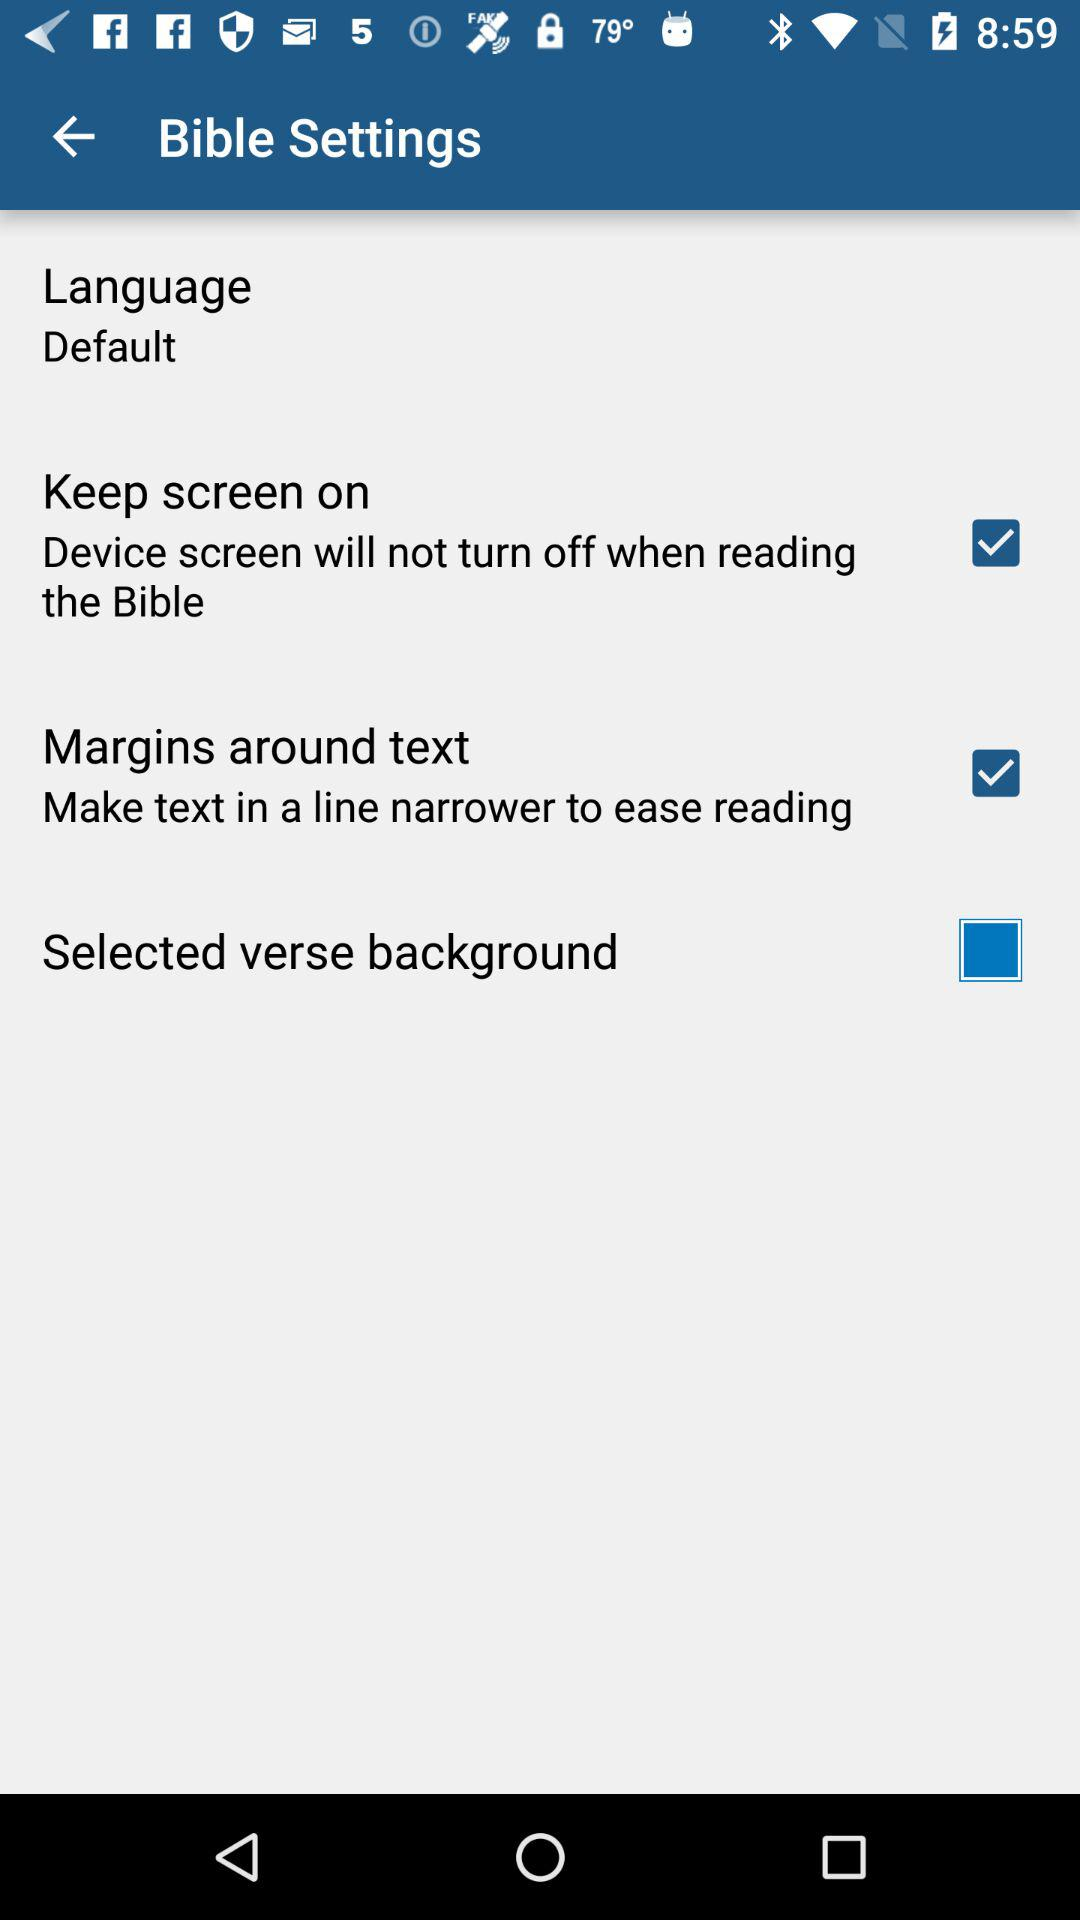How many settings are there?
Answer the question using a single word or phrase. 4 